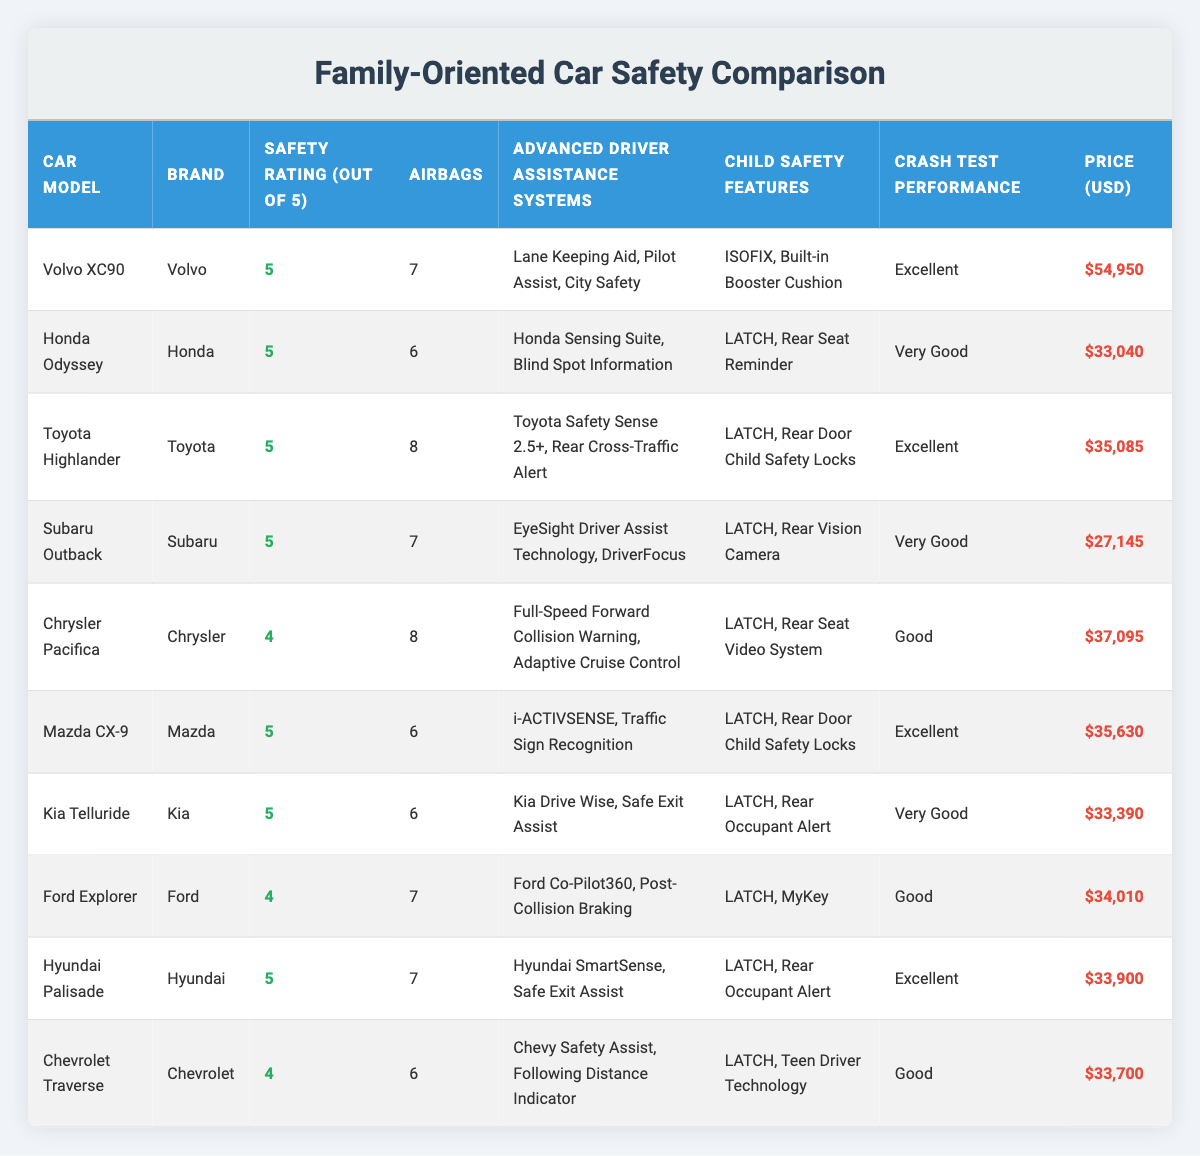What is the safety rating of the Honda Odyssey? The safety rating for the Honda Odyssey is listed in the table under the "Safety Rating (out of 5)" column, which shows a score of 5.
Answer: 5 What car model has the highest number of airbags? In the table, the car model with the highest number of airbags is the Volvo XC90, which has 7 airbags.
Answer: Volvo XC90 Which cars have Child Safety Features using LATCH? The cars with Child Safety Features using LATCH are the Honda Odyssey, Toyota Highlander, Subaru Outback, Mazda CX-9, Kia Telluride, and Hyundai Palisade.
Answer: Honda Odyssey, Toyota Highlander, Subaru Outback, Mazda CX-9, Kia Telluride, Hyundai Palisade Which car offers the most advanced driver assistance systems? The Toyota Highlander provides the most advanced driver assistance systems, which include "Toyota Safety Sense 2.5+" and "Rear Cross-Traffic Alert".
Answer: Toyota Highlander What is the average price of cars with a safety rating of 5? The cars with a safety rating of 5 are: Volvo XC90 ($54,950), Honda Odyssey ($33,040), Toyota Highlander ($35,085), Subaru Outback ($27,145), Mazda CX-9 ($35,630), Kia Telluride ($33,390), and Hyundai Palisade ($33,900). Their total price adds up to $253,230, divided by 7 gives us an average of $36,046.
Answer: $36,046 Is the Chrysler Pacifica rated higher than the Ford Explorer? The safety rating of the Chrysler Pacifica is 4, while the Ford Explorer also has a rating of 4. Therefore, neither car is rated higher.
Answer: No Which vehicle models are priced over $35,000? The vehicle models priced over $35,000 are the Volvo XC90, Toyota Highlander, Hyundai Palisade, and Mazda CX-9.
Answer: Volvo XC90, Toyota Highlander, Hyundai Palisade, Mazda CX-9 How does the crash test performance of the Subaru Outback compare to the Chrysler Pacifica? According to the table, the crash test performance of the Subaru Outback is rated as "Very Good," while the Chrysler Pacifica is rated as "Good." This indicates that the Subaru Outback has a superior crash test performance compared to the Chrysler Pacifica.
Answer: Subaru Outback is better Which brand has the most models listed with a safety rating of 5? The brands Volvo, Honda, Toyota, Subaru, Mazda, Kia, and Hyundai each have one model listed with a safety rating of 5. No brand has more than one model with this rating.
Answer: None What is the difference in price between the most expensive car and the least expensive car in the table? The most expensive car is the Volvo XC90 at $54,950, and the least expensive is the Subaru Outback at $27,145. The difference in price is calculated as $54,950 - $27,145 = $27,805.
Answer: $27,805 